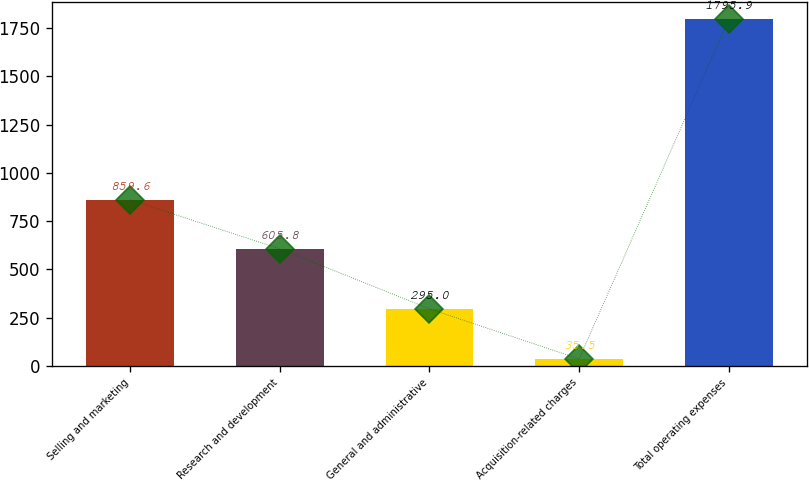Convert chart. <chart><loc_0><loc_0><loc_500><loc_500><bar_chart><fcel>Selling and marketing<fcel>Research and development<fcel>General and administrative<fcel>Acquisition-related charges<fcel>Total operating expenses<nl><fcel>859.6<fcel>605.8<fcel>295<fcel>35.5<fcel>1795.9<nl></chart> 